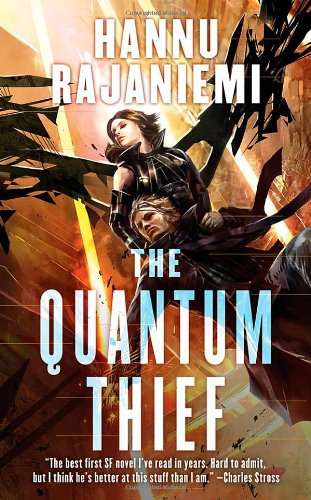How does the cover art reflect the content of the book? The cover art vividly reflects the content with its depiction of an action-packed escape scene likely representing the protagonist's heists, which are central to the plot. The futuristic cityscape suggests advanced technological settings that align with the sci-fi theme. 